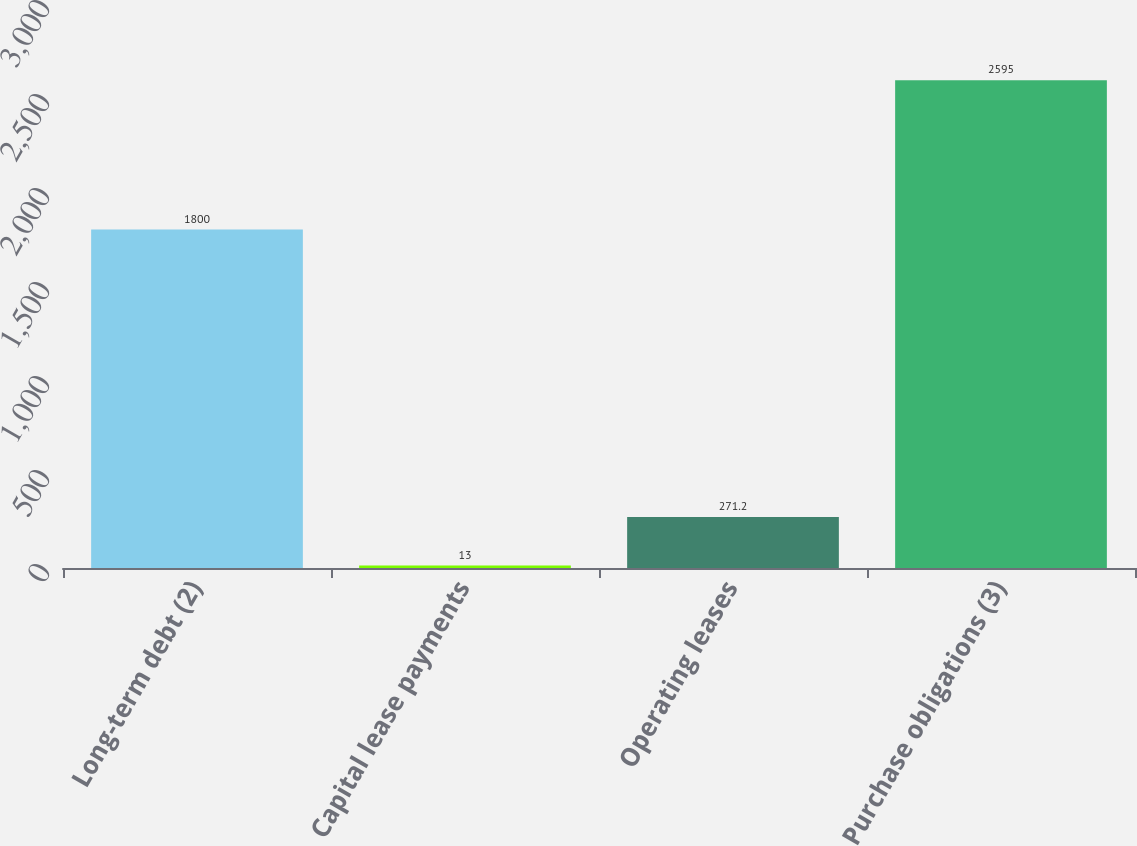Convert chart to OTSL. <chart><loc_0><loc_0><loc_500><loc_500><bar_chart><fcel>Long-term debt (2)<fcel>Capital lease payments<fcel>Operating leases<fcel>Purchase obligations (3)<nl><fcel>1800<fcel>13<fcel>271.2<fcel>2595<nl></chart> 